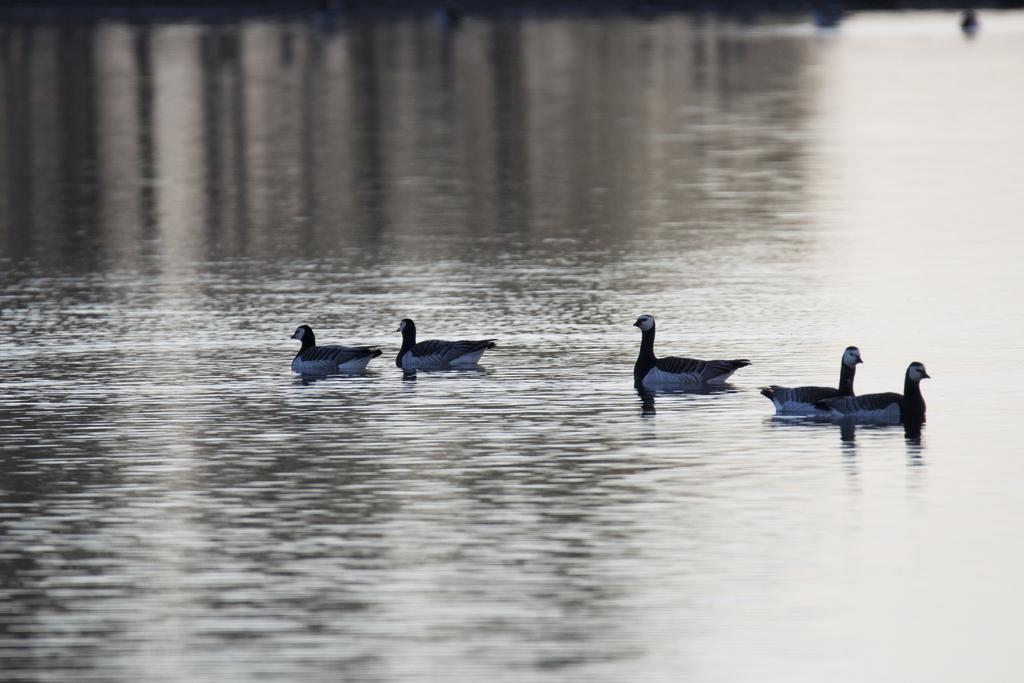What type of animals can be seen in the image? Birds can be seen in the image. Where are the birds located in the image? The birds are in the water. What colors are the birds in the image? The birds are in white and black color. What type of behavior does the father exhibit in the image? There is no father present in the image, as it features birds in the water. 